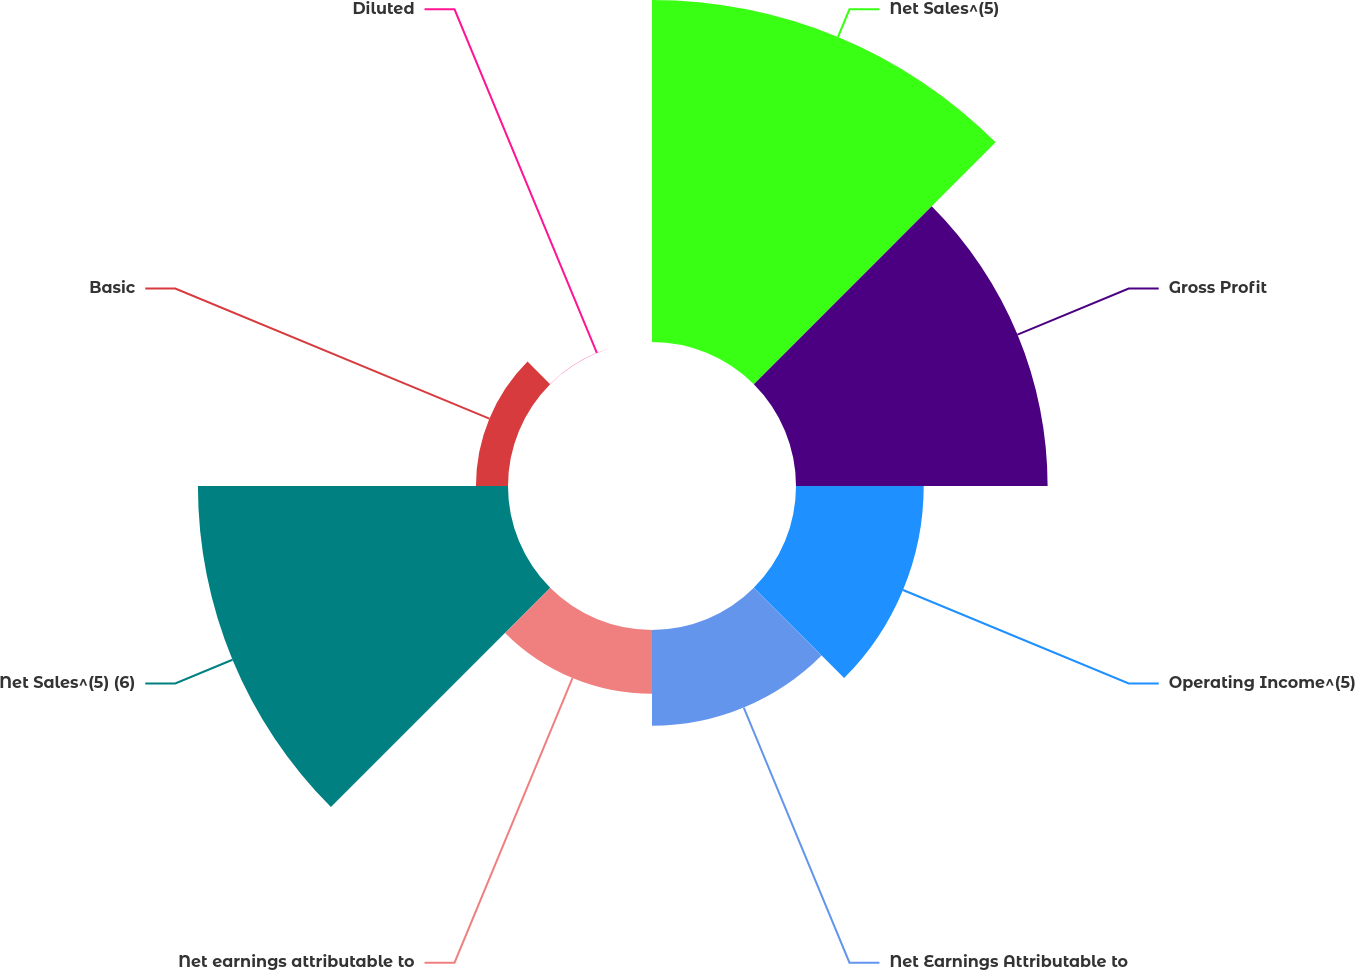<chart> <loc_0><loc_0><loc_500><loc_500><pie_chart><fcel>Net Sales^(5)<fcel>Gross Profit<fcel>Operating Income^(5)<fcel>Net Earnings Attributable to<fcel>Net earnings attributable to<fcel>Net Sales^(5) (6)<fcel>Basic<fcel>Diluted<nl><fcel>27.96%<fcel>20.57%<fcel>10.44%<fcel>7.83%<fcel>5.22%<fcel>25.35%<fcel>2.62%<fcel>0.01%<nl></chart> 